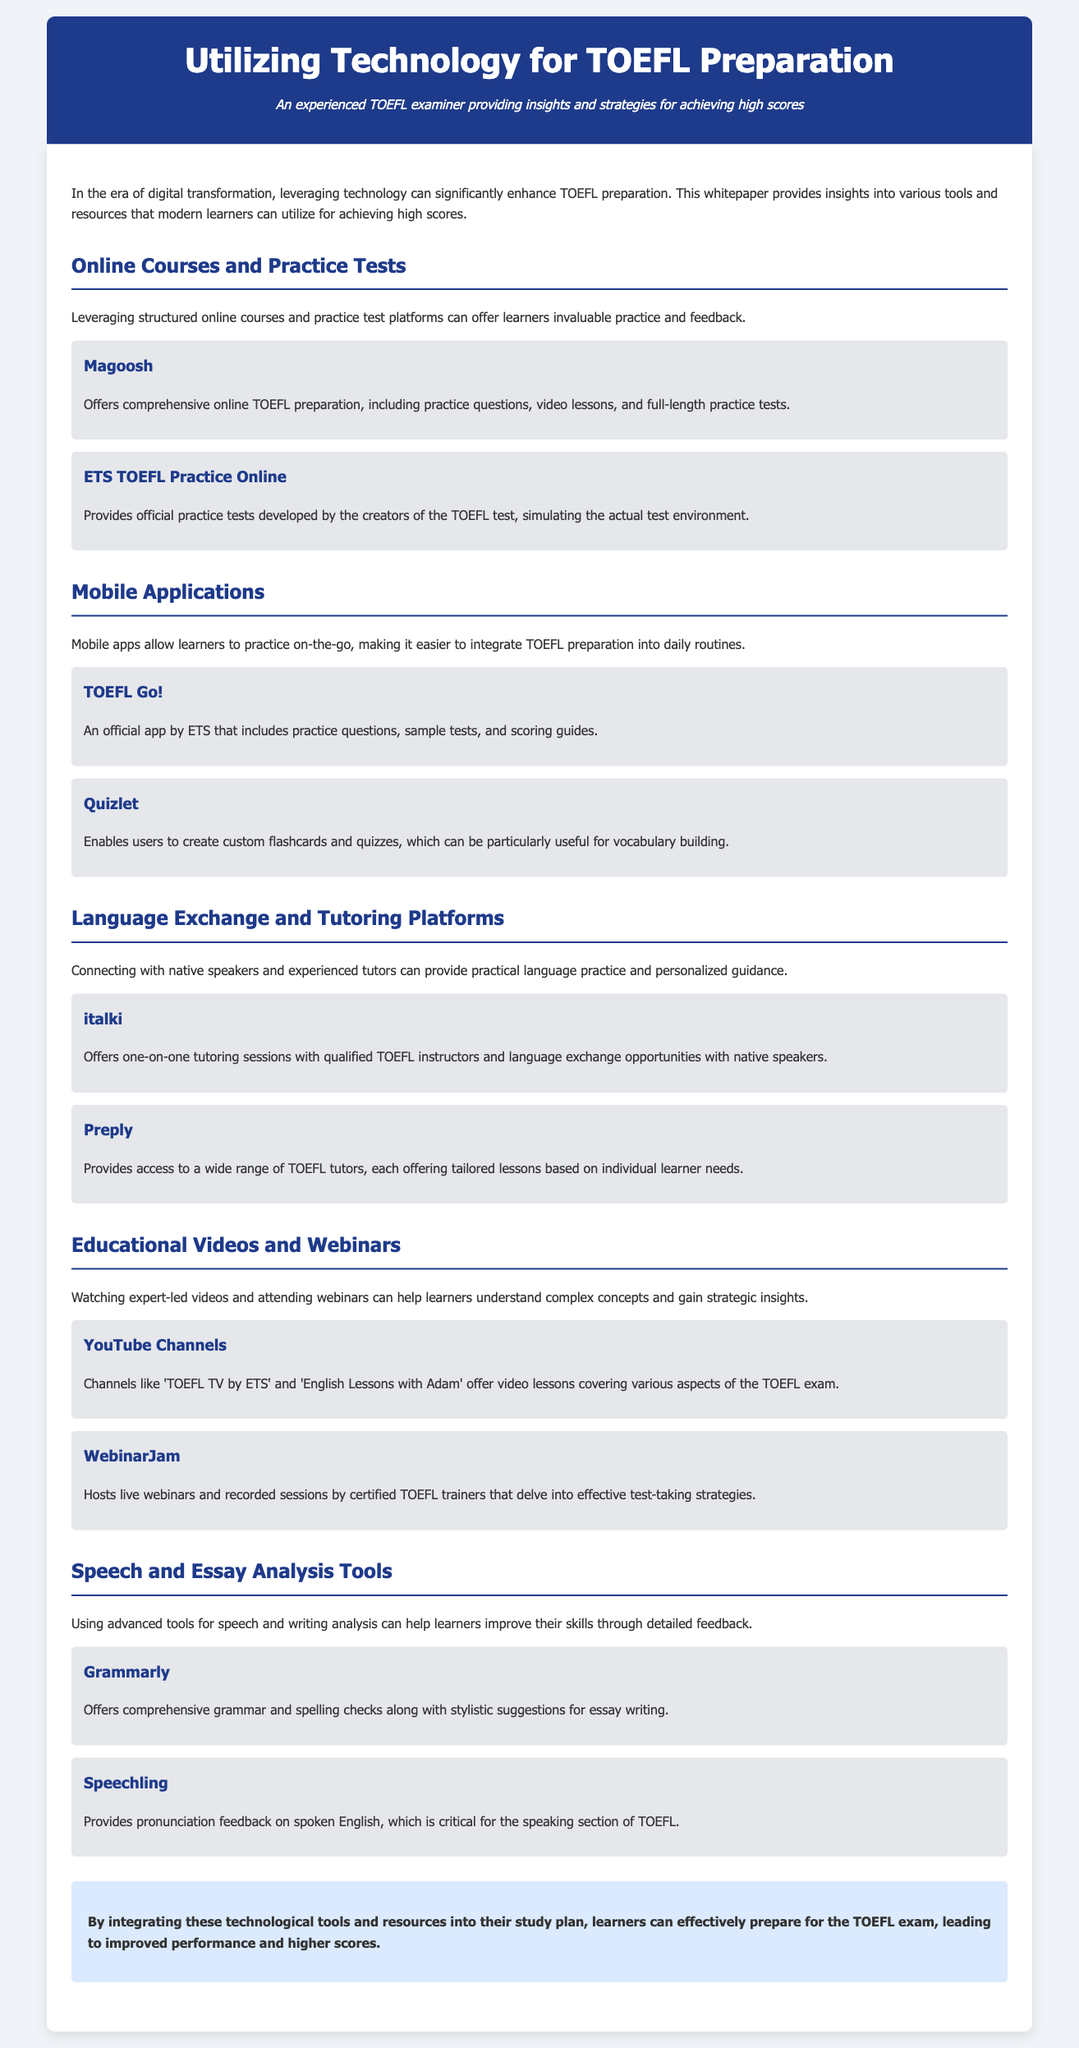what are the online courses mentioned? The document mentions Magoosh and ETS TOEFL Practice Online as online course resources.
Answer: Magoosh, ETS TOEFL Practice Online which mobile application is an official app by ETS? The document specifies that TOEFL Go! is the official app from ETS.
Answer: TOEFL Go! name one platform for language exchange mentioned. The document lists italki and Preply as platforms for language exchange.
Answer: italki what tool does Grammarly provide? Grammarly offers grammar and spelling checks along with stylistic suggestions.
Answer: grammar and spelling checks which type of content can be found on YouTube channels related to TOEFL? The document indicates that YouTube channels offer video lessons covering various aspects of the TOEFL exam.
Answer: video lessons what is the main benefit of using technology in TOEFL preparation according to the conclusion? The document concludes that integrating technology leads to improved performance and higher scores.
Answer: improved performance and higher scores 